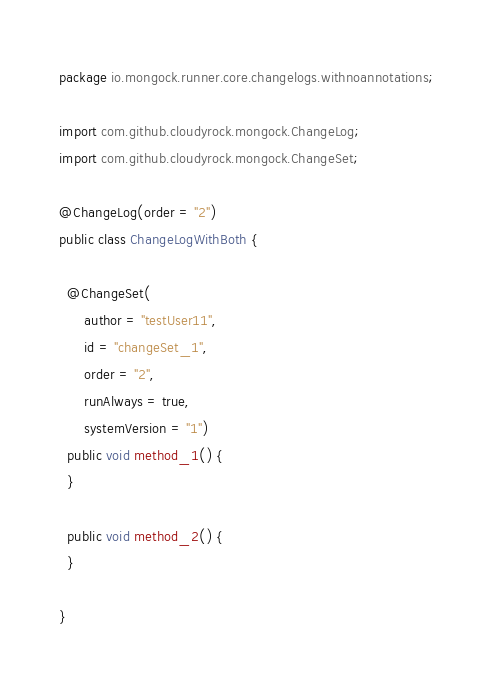Convert code to text. <code><loc_0><loc_0><loc_500><loc_500><_Java_>package io.mongock.runner.core.changelogs.withnoannotations;

import com.github.cloudyrock.mongock.ChangeLog;
import com.github.cloudyrock.mongock.ChangeSet;

@ChangeLog(order = "2")
public class ChangeLogWithBoth {

  @ChangeSet(
      author = "testUser11",
      id = "changeSet_1",
      order = "2",
      runAlways = true,
      systemVersion = "1")
  public void method_1() {
  }

  public void method_2() {
  }

}
</code> 